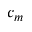Convert formula to latex. <formula><loc_0><loc_0><loc_500><loc_500>c _ { m }</formula> 